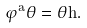<formula> <loc_0><loc_0><loc_500><loc_500>\varphi ^ { a } \theta = \theta h .</formula> 